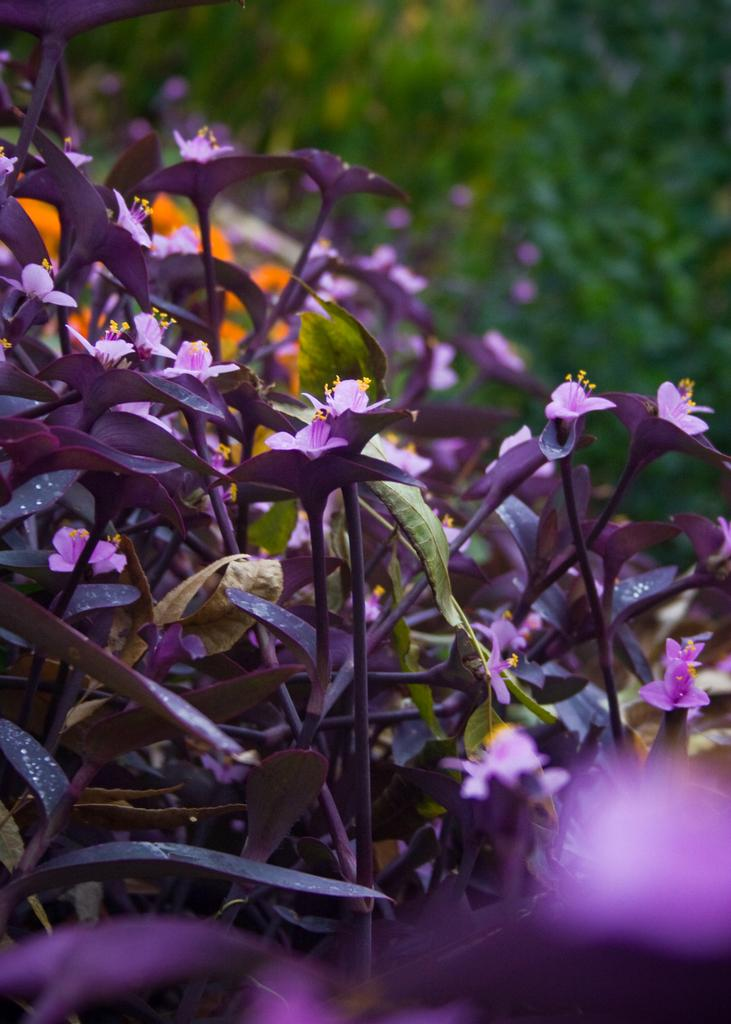What color are the flowers in the image? The flowers in the image are violet. What else can be seen in the image besides the flowers? There are leaves in the image. How would you describe the background of the image? The background of the image is blurry. What type of ink is used to write the name of the shop in the image? There is no shop or writing present in the image, so it is not possible to determine the type of ink used. 